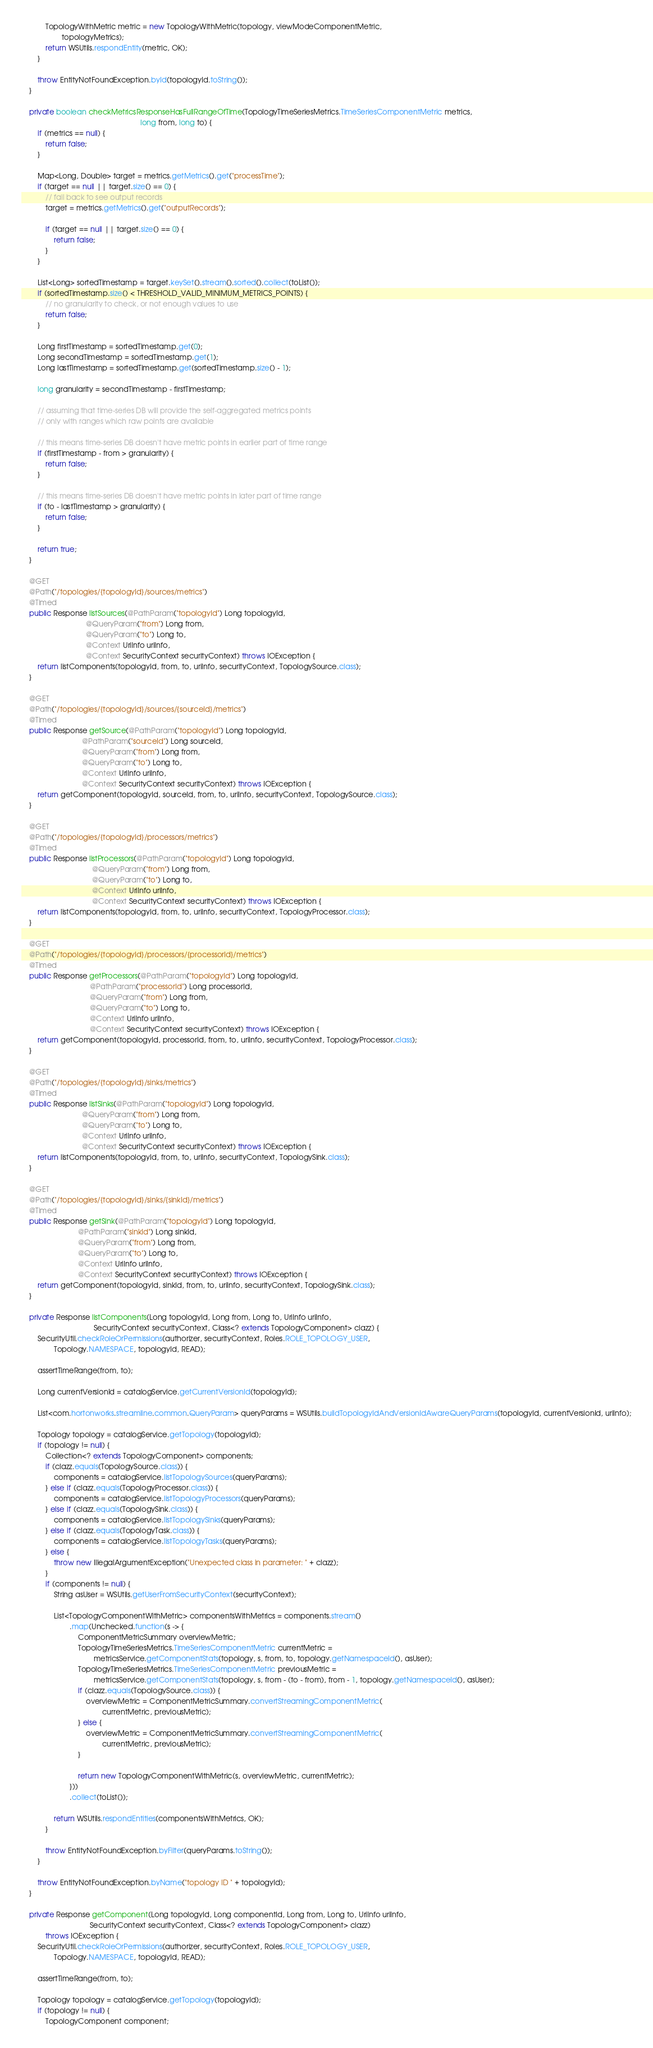<code> <loc_0><loc_0><loc_500><loc_500><_Java_>            TopologyWithMetric metric = new TopologyWithMetric(topology, viewModeComponentMetric,
                    topologyMetrics);
            return WSUtils.respondEntity(metric, OK);
        }

        throw EntityNotFoundException.byId(topologyId.toString());
    }

    private boolean checkMetricsResponseHasFullRangeOfTime(TopologyTimeSeriesMetrics.TimeSeriesComponentMetric metrics,
                                                           long from, long to) {
        if (metrics == null) {
            return false;
        }

        Map<Long, Double> target = metrics.getMetrics().get("processTime");
        if (target == null || target.size() == 0) {
            // fail back to see output records
            target = metrics.getMetrics().get("outputRecords");

            if (target == null || target.size() == 0) {
                return false;
            }
        }

        List<Long> sortedTimestamp = target.keySet().stream().sorted().collect(toList());
        if (sortedTimestamp.size() < THRESHOLD_VALID_MINIMUM_METRICS_POINTS) {
            // no granularity to check, or not enough values to use
            return false;
        }

        Long firstTimestamp = sortedTimestamp.get(0);
        Long secondTimestamp = sortedTimestamp.get(1);
        Long lastTimestamp = sortedTimestamp.get(sortedTimestamp.size() - 1);

        long granularity = secondTimestamp - firstTimestamp;

        // assuming that time-series DB will provide the self-aggregated metrics points
        // only with ranges which raw points are available

        // this means time-series DB doesn't have metric points in earlier part of time range
        if (firstTimestamp - from > granularity) {
            return false;
        }

        // this means time-series DB doesn't have metric points in later part of time range
        if (to - lastTimestamp > granularity) {
            return false;
        }

        return true;
    }

    @GET
    @Path("/topologies/{topologyId}/sources/metrics")
    @Timed
    public Response listSources(@PathParam("topologyId") Long topologyId,
                                @QueryParam("from") Long from,
                                @QueryParam("to") Long to,
                                @Context UriInfo uriInfo,
                                @Context SecurityContext securityContext) throws IOException {
        return listComponents(topologyId, from, to, uriInfo, securityContext, TopologySource.class);
    }

    @GET
    @Path("/topologies/{topologyId}/sources/{sourceId}/metrics")
    @Timed
    public Response getSource(@PathParam("topologyId") Long topologyId,
                              @PathParam("sourceId") Long sourceId,
                              @QueryParam("from") Long from,
                              @QueryParam("to") Long to,
                              @Context UriInfo uriInfo,
                              @Context SecurityContext securityContext) throws IOException {
        return getComponent(topologyId, sourceId, from, to, uriInfo, securityContext, TopologySource.class);
    }

    @GET
    @Path("/topologies/{topologyId}/processors/metrics")
    @Timed
    public Response listProcessors(@PathParam("topologyId") Long topologyId,
                                   @QueryParam("from") Long from,
                                   @QueryParam("to") Long to,
                                   @Context UriInfo uriInfo,
                                   @Context SecurityContext securityContext) throws IOException {
        return listComponents(topologyId, from, to, uriInfo, securityContext, TopologyProcessor.class);
    }

    @GET
    @Path("/topologies/{topologyId}/processors/{processorId}/metrics")
    @Timed
    public Response getProcessors(@PathParam("topologyId") Long topologyId,
                                  @PathParam("processorId") Long processorId,
                                  @QueryParam("from") Long from,
                                  @QueryParam("to") Long to,
                                  @Context UriInfo uriInfo,
                                  @Context SecurityContext securityContext) throws IOException {
        return getComponent(topologyId, processorId, from, to, uriInfo, securityContext, TopologyProcessor.class);
    }

    @GET
    @Path("/topologies/{topologyId}/sinks/metrics")
    @Timed
    public Response listSinks(@PathParam("topologyId") Long topologyId,
                              @QueryParam("from") Long from,
                              @QueryParam("to") Long to,
                              @Context UriInfo uriInfo,
                              @Context SecurityContext securityContext) throws IOException {
        return listComponents(topologyId, from, to, uriInfo, securityContext, TopologySink.class);
    }

    @GET
    @Path("/topologies/{topologyId}/sinks/{sinkId}/metrics")
    @Timed
    public Response getSink(@PathParam("topologyId") Long topologyId,
                            @PathParam("sinkId") Long sinkId,
                            @QueryParam("from") Long from,
                            @QueryParam("to") Long to,
                            @Context UriInfo uriInfo,
                            @Context SecurityContext securityContext) throws IOException {
        return getComponent(topologyId, sinkId, from, to, uriInfo, securityContext, TopologySink.class);
    }

    private Response listComponents(Long topologyId, Long from, Long to, UriInfo uriInfo,
                                    SecurityContext securityContext, Class<? extends TopologyComponent> clazz) {
        SecurityUtil.checkRoleOrPermissions(authorizer, securityContext, Roles.ROLE_TOPOLOGY_USER,
                Topology.NAMESPACE, topologyId, READ);

        assertTimeRange(from, to);

        Long currentVersionId = catalogService.getCurrentVersionId(topologyId);

        List<com.hortonworks.streamline.common.QueryParam> queryParams = WSUtils.buildTopologyIdAndVersionIdAwareQueryParams(topologyId, currentVersionId, uriInfo);

        Topology topology = catalogService.getTopology(topologyId);
        if (topology != null) {
            Collection<? extends TopologyComponent> components;
            if (clazz.equals(TopologySource.class)) {
                components = catalogService.listTopologySources(queryParams);
            } else if (clazz.equals(TopologyProcessor.class)) {
                components = catalogService.listTopologyProcessors(queryParams);
            } else if (clazz.equals(TopologySink.class)) {
                components = catalogService.listTopologySinks(queryParams);
            } else if (clazz.equals(TopologyTask.class)) {
                components = catalogService.listTopologyTasks(queryParams);
            } else {
                throw new IllegalArgumentException("Unexpected class in parameter: " + clazz);
            }
            if (components != null) {
                String asUser = WSUtils.getUserFromSecurityContext(securityContext);

                List<TopologyComponentWithMetric> componentsWithMetrics = components.stream()
                        .map(Unchecked.function(s -> {
                            ComponentMetricSummary overviewMetric;
                            TopologyTimeSeriesMetrics.TimeSeriesComponentMetric currentMetric =
                                    metricsService.getComponentStats(topology, s, from, to, topology.getNamespaceId(), asUser);
                            TopologyTimeSeriesMetrics.TimeSeriesComponentMetric previousMetric =
                                    metricsService.getComponentStats(topology, s, from - (to - from), from - 1, topology.getNamespaceId(), asUser);
                            if (clazz.equals(TopologySource.class)) {
                                overviewMetric = ComponentMetricSummary.convertStreamingComponentMetric(
                                        currentMetric, previousMetric);
                            } else {
                                overviewMetric = ComponentMetricSummary.convertStreamingComponentMetric(
                                        currentMetric, previousMetric);
                            }

                            return new TopologyComponentWithMetric(s, overviewMetric, currentMetric);
                        }))
                        .collect(toList());

                return WSUtils.respondEntities(componentsWithMetrics, OK);
            }

            throw EntityNotFoundException.byFilter(queryParams.toString());
        }

        throw EntityNotFoundException.byName("topology ID " + topologyId);
    }

    private Response getComponent(Long topologyId, Long componentId, Long from, Long to, UriInfo uriInfo,
                                  SecurityContext securityContext, Class<? extends TopologyComponent> clazz)
            throws IOException {
        SecurityUtil.checkRoleOrPermissions(authorizer, securityContext, Roles.ROLE_TOPOLOGY_USER,
                Topology.NAMESPACE, topologyId, READ);

        assertTimeRange(from, to);

        Topology topology = catalogService.getTopology(topologyId);
        if (topology != null) {
            TopologyComponent component;</code> 